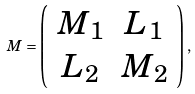Convert formula to latex. <formula><loc_0><loc_0><loc_500><loc_500>M = \left ( \begin{array} { c c } M _ { 1 } & L _ { 1 } \\ L _ { 2 } & M _ { 2 } \end{array} \right ) ,</formula> 